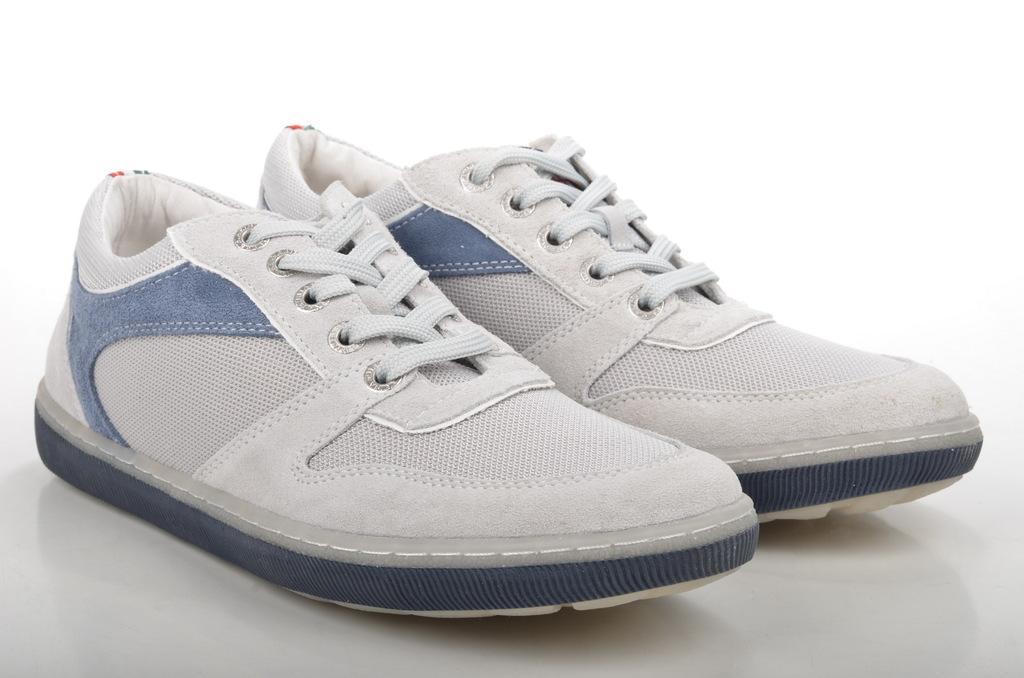Can you describe this image briefly? In this image we can see white shoes on a white surface. 